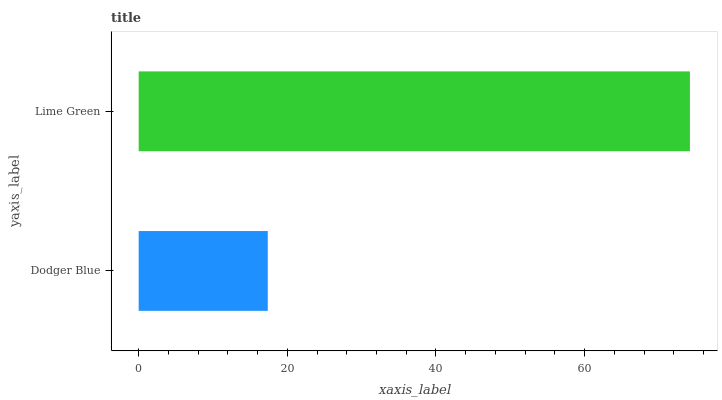Is Dodger Blue the minimum?
Answer yes or no. Yes. Is Lime Green the maximum?
Answer yes or no. Yes. Is Lime Green the minimum?
Answer yes or no. No. Is Lime Green greater than Dodger Blue?
Answer yes or no. Yes. Is Dodger Blue less than Lime Green?
Answer yes or no. Yes. Is Dodger Blue greater than Lime Green?
Answer yes or no. No. Is Lime Green less than Dodger Blue?
Answer yes or no. No. Is Lime Green the high median?
Answer yes or no. Yes. Is Dodger Blue the low median?
Answer yes or no. Yes. Is Dodger Blue the high median?
Answer yes or no. No. Is Lime Green the low median?
Answer yes or no. No. 